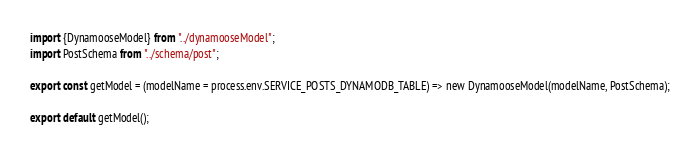<code> <loc_0><loc_0><loc_500><loc_500><_JavaScript_>import {DynamooseModel} from "../dynamooseModel";
import PostSchema from "../schema/post";

export const getModel = (modelName = process.env.SERVICE_POSTS_DYNAMODB_TABLE) => new DynamooseModel(modelName, PostSchema);

export default getModel();
</code> 